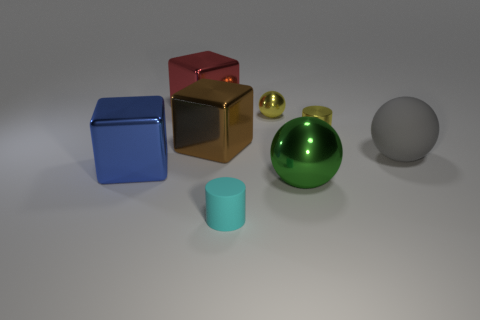Subtract all big rubber balls. How many balls are left? 2 Add 1 tiny gray rubber blocks. How many objects exist? 9 Subtract all cylinders. How many objects are left? 6 Add 7 small shiny objects. How many small shiny objects exist? 9 Subtract 0 cyan balls. How many objects are left? 8 Subtract all brown things. Subtract all tiny yellow metallic cylinders. How many objects are left? 6 Add 4 red blocks. How many red blocks are left? 5 